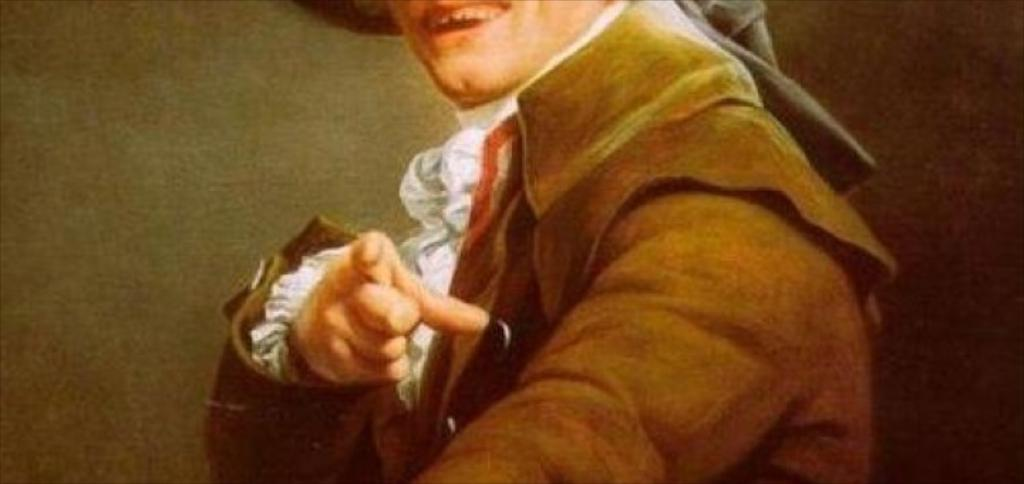What is the main subject of the image? There is a person in the image. What is the person wearing in the image? The person is wearing a jacket. What type of car is parked next to the person in the image? There is no car present in the image; it only features a person wearing a jacket. 